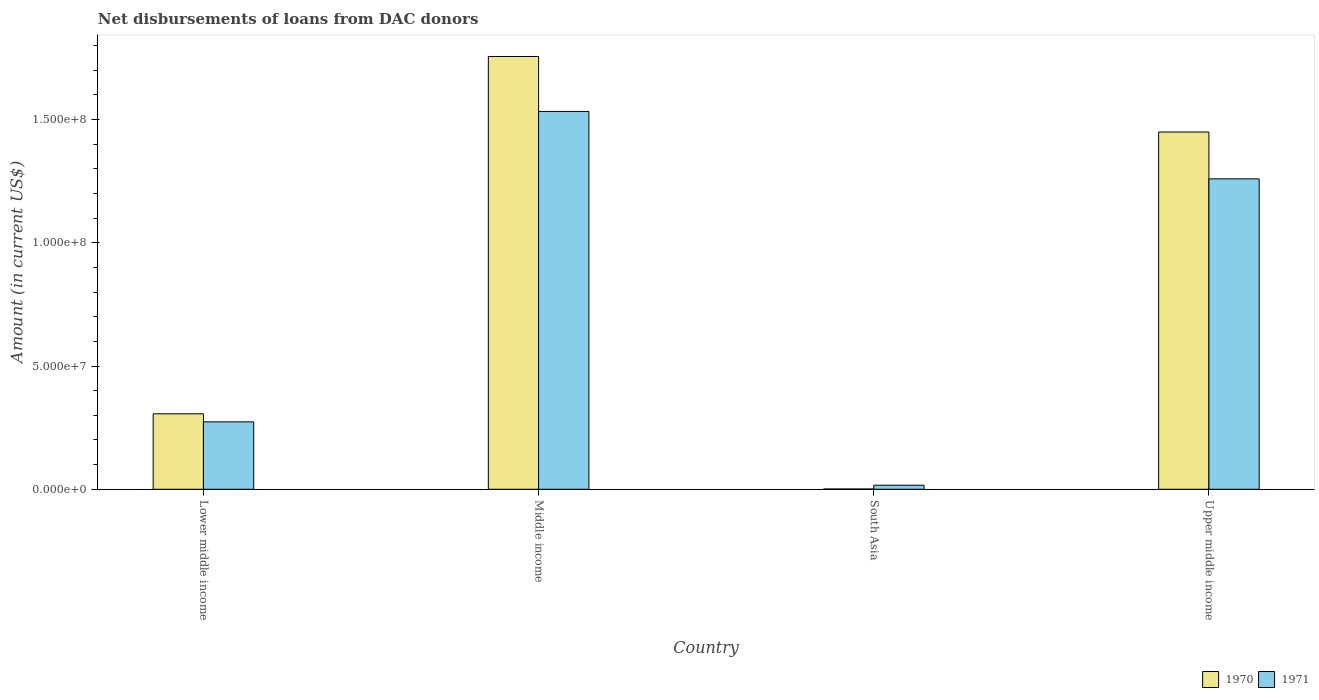How many different coloured bars are there?
Make the answer very short. 2. How many groups of bars are there?
Your answer should be very brief. 4. Are the number of bars on each tick of the X-axis equal?
Ensure brevity in your answer.  Yes. How many bars are there on the 2nd tick from the left?
Make the answer very short. 2. In how many cases, is the number of bars for a given country not equal to the number of legend labels?
Ensure brevity in your answer.  0. What is the amount of loans disbursed in 1970 in South Asia?
Offer a terse response. 1.09e+05. Across all countries, what is the maximum amount of loans disbursed in 1971?
Your answer should be very brief. 1.53e+08. Across all countries, what is the minimum amount of loans disbursed in 1971?
Keep it short and to the point. 1.65e+06. In which country was the amount of loans disbursed in 1971 maximum?
Give a very brief answer. Middle income. What is the total amount of loans disbursed in 1970 in the graph?
Your answer should be very brief. 3.51e+08. What is the difference between the amount of loans disbursed in 1970 in Lower middle income and that in Upper middle income?
Your response must be concise. -1.14e+08. What is the difference between the amount of loans disbursed in 1970 in Middle income and the amount of loans disbursed in 1971 in Lower middle income?
Ensure brevity in your answer.  1.48e+08. What is the average amount of loans disbursed in 1971 per country?
Keep it short and to the point. 7.70e+07. What is the difference between the amount of loans disbursed of/in 1970 and amount of loans disbursed of/in 1971 in Lower middle income?
Offer a terse response. 3.27e+06. In how many countries, is the amount of loans disbursed in 1970 greater than 110000000 US$?
Offer a very short reply. 2. What is the ratio of the amount of loans disbursed in 1970 in Middle income to that in Upper middle income?
Provide a succinct answer. 1.21. Is the amount of loans disbursed in 1971 in Lower middle income less than that in South Asia?
Keep it short and to the point. No. Is the difference between the amount of loans disbursed in 1970 in Lower middle income and Upper middle income greater than the difference between the amount of loans disbursed in 1971 in Lower middle income and Upper middle income?
Give a very brief answer. No. What is the difference between the highest and the second highest amount of loans disbursed in 1970?
Make the answer very short. 1.45e+08. What is the difference between the highest and the lowest amount of loans disbursed in 1970?
Ensure brevity in your answer.  1.75e+08. In how many countries, is the amount of loans disbursed in 1971 greater than the average amount of loans disbursed in 1971 taken over all countries?
Your answer should be compact. 2. Is the sum of the amount of loans disbursed in 1970 in Lower middle income and South Asia greater than the maximum amount of loans disbursed in 1971 across all countries?
Make the answer very short. No. What does the 1st bar from the left in Upper middle income represents?
Offer a terse response. 1970. How many countries are there in the graph?
Your response must be concise. 4. Does the graph contain grids?
Offer a very short reply. No. How many legend labels are there?
Provide a succinct answer. 2. What is the title of the graph?
Ensure brevity in your answer.  Net disbursements of loans from DAC donors. Does "1975" appear as one of the legend labels in the graph?
Ensure brevity in your answer.  No. What is the label or title of the X-axis?
Ensure brevity in your answer.  Country. What is the label or title of the Y-axis?
Keep it short and to the point. Amount (in current US$). What is the Amount (in current US$) in 1970 in Lower middle income?
Offer a terse response. 3.06e+07. What is the Amount (in current US$) in 1971 in Lower middle income?
Your answer should be very brief. 2.74e+07. What is the Amount (in current US$) in 1970 in Middle income?
Keep it short and to the point. 1.76e+08. What is the Amount (in current US$) in 1971 in Middle income?
Your response must be concise. 1.53e+08. What is the Amount (in current US$) in 1970 in South Asia?
Make the answer very short. 1.09e+05. What is the Amount (in current US$) in 1971 in South Asia?
Ensure brevity in your answer.  1.65e+06. What is the Amount (in current US$) in 1970 in Upper middle income?
Give a very brief answer. 1.45e+08. What is the Amount (in current US$) of 1971 in Upper middle income?
Give a very brief answer. 1.26e+08. Across all countries, what is the maximum Amount (in current US$) in 1970?
Make the answer very short. 1.76e+08. Across all countries, what is the maximum Amount (in current US$) in 1971?
Ensure brevity in your answer.  1.53e+08. Across all countries, what is the minimum Amount (in current US$) in 1970?
Offer a very short reply. 1.09e+05. Across all countries, what is the minimum Amount (in current US$) of 1971?
Your answer should be very brief. 1.65e+06. What is the total Amount (in current US$) of 1970 in the graph?
Ensure brevity in your answer.  3.51e+08. What is the total Amount (in current US$) of 1971 in the graph?
Keep it short and to the point. 3.08e+08. What is the difference between the Amount (in current US$) of 1970 in Lower middle income and that in Middle income?
Provide a short and direct response. -1.45e+08. What is the difference between the Amount (in current US$) of 1971 in Lower middle income and that in Middle income?
Your answer should be compact. -1.26e+08. What is the difference between the Amount (in current US$) in 1970 in Lower middle income and that in South Asia?
Offer a terse response. 3.05e+07. What is the difference between the Amount (in current US$) in 1971 in Lower middle income and that in South Asia?
Offer a terse response. 2.57e+07. What is the difference between the Amount (in current US$) of 1970 in Lower middle income and that in Upper middle income?
Make the answer very short. -1.14e+08. What is the difference between the Amount (in current US$) in 1971 in Lower middle income and that in Upper middle income?
Keep it short and to the point. -9.86e+07. What is the difference between the Amount (in current US$) in 1970 in Middle income and that in South Asia?
Keep it short and to the point. 1.75e+08. What is the difference between the Amount (in current US$) in 1971 in Middle income and that in South Asia?
Provide a succinct answer. 1.52e+08. What is the difference between the Amount (in current US$) in 1970 in Middle income and that in Upper middle income?
Offer a very short reply. 3.06e+07. What is the difference between the Amount (in current US$) in 1971 in Middle income and that in Upper middle income?
Make the answer very short. 2.74e+07. What is the difference between the Amount (in current US$) in 1970 in South Asia and that in Upper middle income?
Ensure brevity in your answer.  -1.45e+08. What is the difference between the Amount (in current US$) of 1971 in South Asia and that in Upper middle income?
Provide a succinct answer. -1.24e+08. What is the difference between the Amount (in current US$) of 1970 in Lower middle income and the Amount (in current US$) of 1971 in Middle income?
Give a very brief answer. -1.23e+08. What is the difference between the Amount (in current US$) in 1970 in Lower middle income and the Amount (in current US$) in 1971 in South Asia?
Your answer should be very brief. 2.90e+07. What is the difference between the Amount (in current US$) in 1970 in Lower middle income and the Amount (in current US$) in 1971 in Upper middle income?
Provide a short and direct response. -9.53e+07. What is the difference between the Amount (in current US$) of 1970 in Middle income and the Amount (in current US$) of 1971 in South Asia?
Ensure brevity in your answer.  1.74e+08. What is the difference between the Amount (in current US$) in 1970 in Middle income and the Amount (in current US$) in 1971 in Upper middle income?
Keep it short and to the point. 4.96e+07. What is the difference between the Amount (in current US$) of 1970 in South Asia and the Amount (in current US$) of 1971 in Upper middle income?
Give a very brief answer. -1.26e+08. What is the average Amount (in current US$) of 1970 per country?
Your answer should be very brief. 8.78e+07. What is the average Amount (in current US$) in 1971 per country?
Give a very brief answer. 7.70e+07. What is the difference between the Amount (in current US$) in 1970 and Amount (in current US$) in 1971 in Lower middle income?
Your answer should be compact. 3.27e+06. What is the difference between the Amount (in current US$) in 1970 and Amount (in current US$) in 1971 in Middle income?
Your response must be concise. 2.23e+07. What is the difference between the Amount (in current US$) in 1970 and Amount (in current US$) in 1971 in South Asia?
Give a very brief answer. -1.54e+06. What is the difference between the Amount (in current US$) of 1970 and Amount (in current US$) of 1971 in Upper middle income?
Offer a very short reply. 1.90e+07. What is the ratio of the Amount (in current US$) in 1970 in Lower middle income to that in Middle income?
Your response must be concise. 0.17. What is the ratio of the Amount (in current US$) of 1971 in Lower middle income to that in Middle income?
Give a very brief answer. 0.18. What is the ratio of the Amount (in current US$) in 1970 in Lower middle income to that in South Asia?
Your answer should be compact. 280.94. What is the ratio of the Amount (in current US$) of 1971 in Lower middle income to that in South Asia?
Offer a very short reply. 16.58. What is the ratio of the Amount (in current US$) of 1970 in Lower middle income to that in Upper middle income?
Keep it short and to the point. 0.21. What is the ratio of the Amount (in current US$) of 1971 in Lower middle income to that in Upper middle income?
Your answer should be very brief. 0.22. What is the ratio of the Amount (in current US$) in 1970 in Middle income to that in South Asia?
Your response must be concise. 1610.58. What is the ratio of the Amount (in current US$) of 1971 in Middle income to that in South Asia?
Provide a short and direct response. 92.89. What is the ratio of the Amount (in current US$) of 1970 in Middle income to that in Upper middle income?
Your response must be concise. 1.21. What is the ratio of the Amount (in current US$) in 1971 in Middle income to that in Upper middle income?
Your answer should be compact. 1.22. What is the ratio of the Amount (in current US$) of 1970 in South Asia to that in Upper middle income?
Keep it short and to the point. 0. What is the ratio of the Amount (in current US$) in 1971 in South Asia to that in Upper middle income?
Keep it short and to the point. 0.01. What is the difference between the highest and the second highest Amount (in current US$) of 1970?
Offer a terse response. 3.06e+07. What is the difference between the highest and the second highest Amount (in current US$) in 1971?
Your answer should be very brief. 2.74e+07. What is the difference between the highest and the lowest Amount (in current US$) of 1970?
Your response must be concise. 1.75e+08. What is the difference between the highest and the lowest Amount (in current US$) of 1971?
Give a very brief answer. 1.52e+08. 